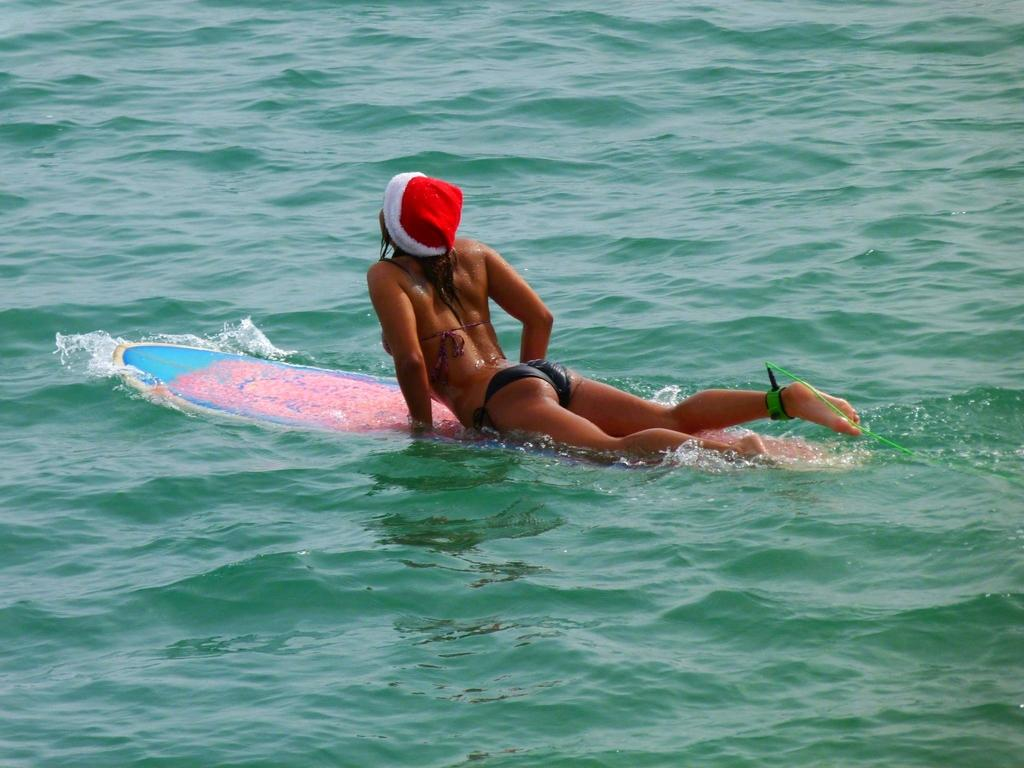Who is the main subject in the image? There is a woman in the image. What is the woman doing in the image? The woman is lying on a surfing board. What can be seen around the woman? There is water around the woman. How many bikes are parked next to the woman in the image? There are no bikes present in the image. What are the girls doing in the image? There are no girls mentioned in the image; only a woman is present. 